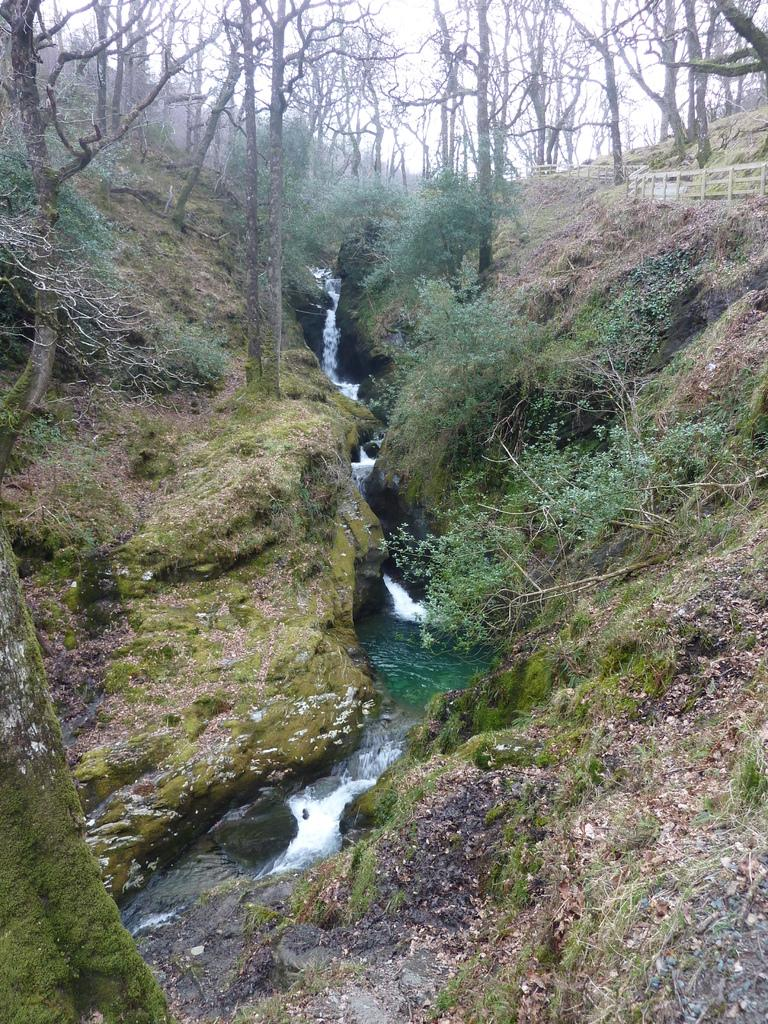What type of vegetation can be seen in the image? There are trees and bushes in the image. What natural feature is depicted in the image? There is water flowing in the image. What type of landscape is shown in the image? The image appears to depict hills. What is on the right side of the image? There is a wooden fence on the right side of the image. Can you see the wound on the jellyfish in the image? There is no jellyfish present in the image, and therefore no wound can be observed. Who is the owner of the wooden fence in the image? The image does not provide information about the ownership of the wooden fence, so it cannot be determined. 